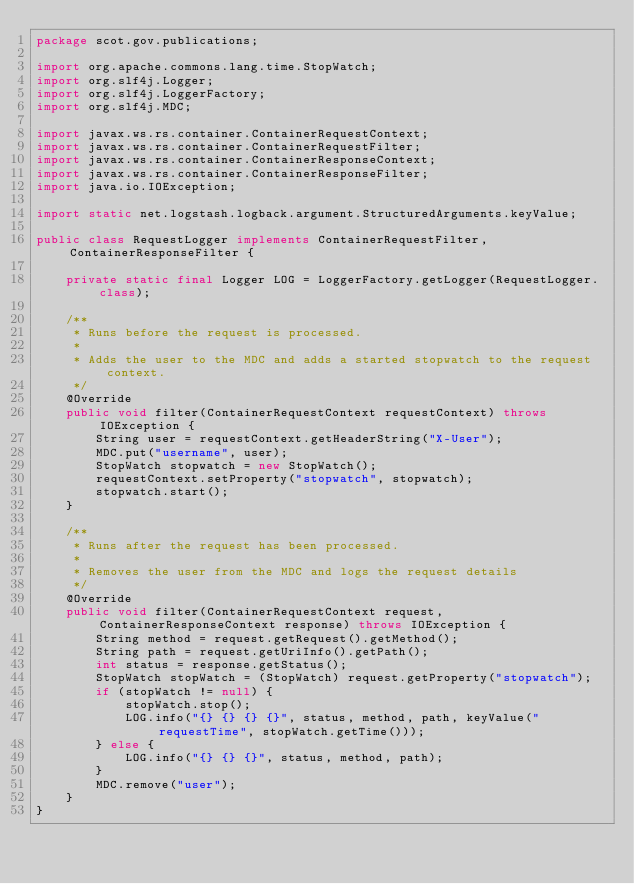Convert code to text. <code><loc_0><loc_0><loc_500><loc_500><_Java_>package scot.gov.publications;

import org.apache.commons.lang.time.StopWatch;
import org.slf4j.Logger;
import org.slf4j.LoggerFactory;
import org.slf4j.MDC;

import javax.ws.rs.container.ContainerRequestContext;
import javax.ws.rs.container.ContainerRequestFilter;
import javax.ws.rs.container.ContainerResponseContext;
import javax.ws.rs.container.ContainerResponseFilter;
import java.io.IOException;

import static net.logstash.logback.argument.StructuredArguments.keyValue;

public class RequestLogger implements ContainerRequestFilter, ContainerResponseFilter {

    private static final Logger LOG = LoggerFactory.getLogger(RequestLogger.class);

    /**
     * Runs before the request is processed.
     *
     * Adds the user to the MDC and adds a started stopwatch to the request context.
     */
    @Override
    public void filter(ContainerRequestContext requestContext) throws IOException {
        String user = requestContext.getHeaderString("X-User");
        MDC.put("username", user);
        StopWatch stopwatch = new StopWatch();
        requestContext.setProperty("stopwatch", stopwatch);
        stopwatch.start();
    }

    /**
     * Runs after the request has been processed.
     *
     * Removes the user from the MDC and logs the request details
     */
    @Override
    public void filter(ContainerRequestContext request, ContainerResponseContext response) throws IOException {
        String method = request.getRequest().getMethod();
        String path = request.getUriInfo().getPath();
        int status = response.getStatus();
        StopWatch stopWatch = (StopWatch) request.getProperty("stopwatch");
        if (stopWatch != null) {
            stopWatch.stop();
            LOG.info("{} {} {} {}", status, method, path, keyValue("requestTime", stopWatch.getTime()));
        } else {
            LOG.info("{} {} {}", status, method, path);
        }
        MDC.remove("user");
    }
}
</code> 